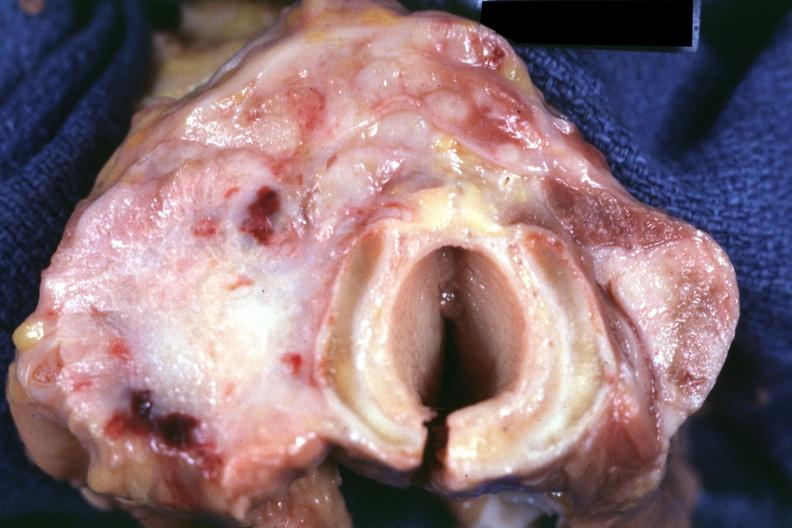what had metastases to lungs, pleura, liver and regional nodes?
Answer the question using a single word or phrase. Carcinoma 